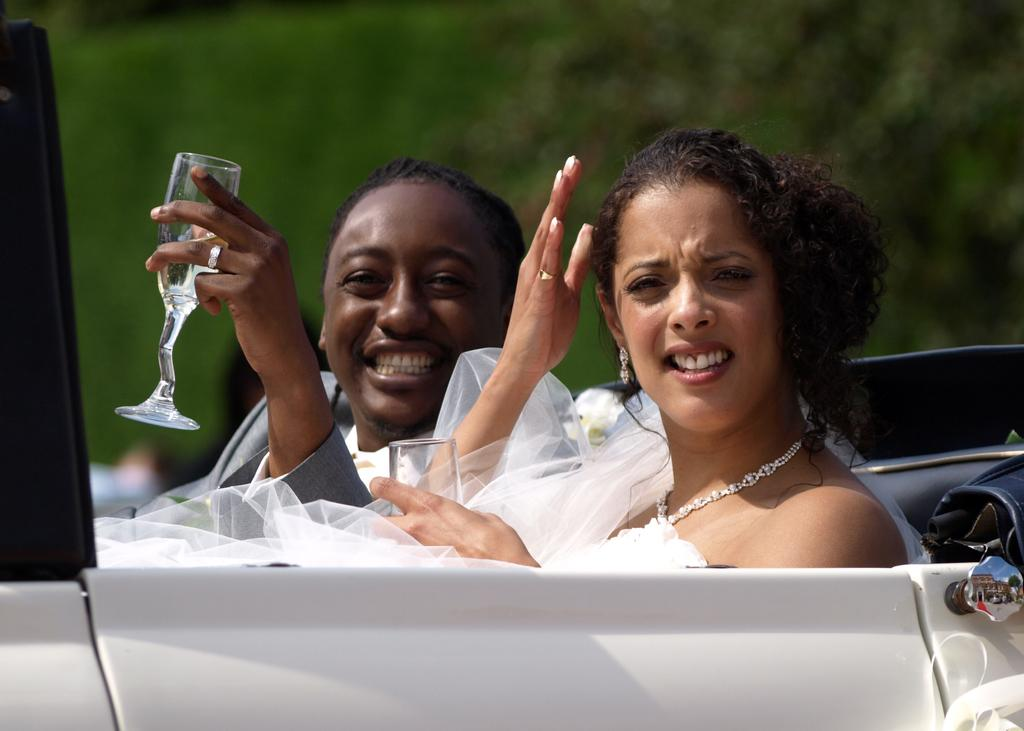How many people are in the image? There are two persons in the image. What are the persons doing in the image? The persons are riding a car. Can you describe the man's action in the image? The man is holding a wine glass in his hand. What is the woman wearing in the image? The woman is wearing a white wedding dress. What can be seen in the background of the image? There is greenery in the background of the image. What type of playground equipment can be seen in the image? There is no playground equipment present in the image. What color is the scarf that the man is wearing in the image? The man is not wearing a scarf in the image; he is holding a wine glass. 